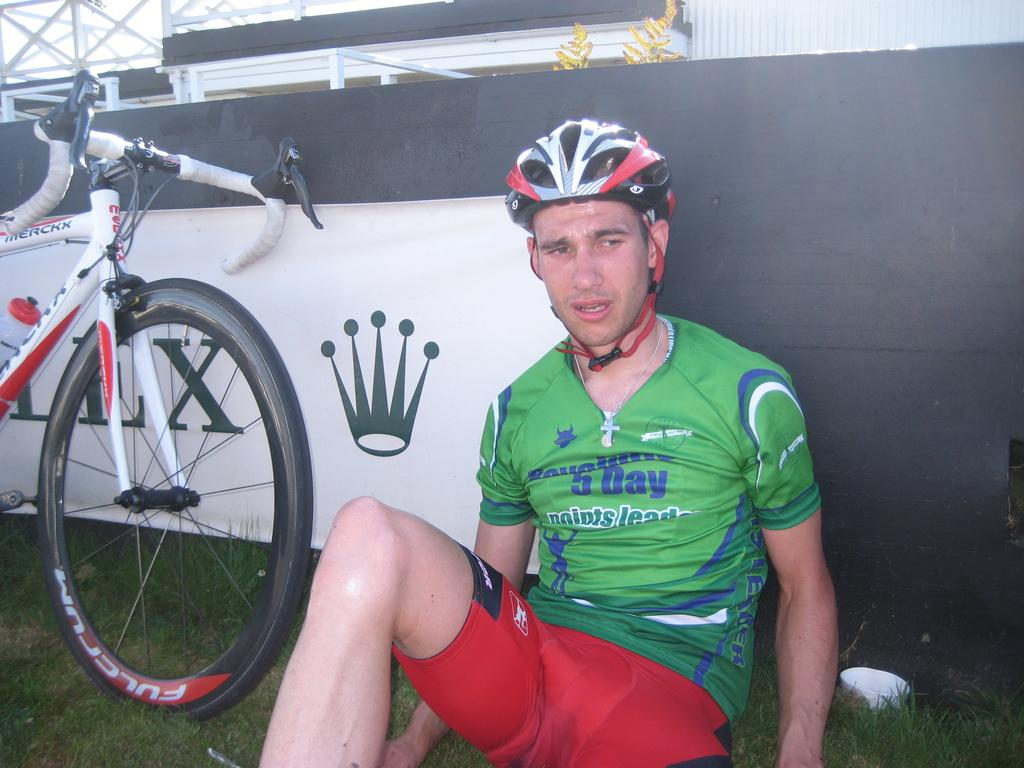What is the man in the image doing? The man is sitting in the image. What can be seen on the left side of the image? There is a bicycle on the left side of the image. What is visible in the background of the image? There is a board and sheds in the background of the image. What type of vegetation is present in the image? There is: There is a tree and grass at the bottom of the image. What is the man's reaction to the waves in the image? There are no waves present in the image, so it is not possible to determine the man's reaction to them. 